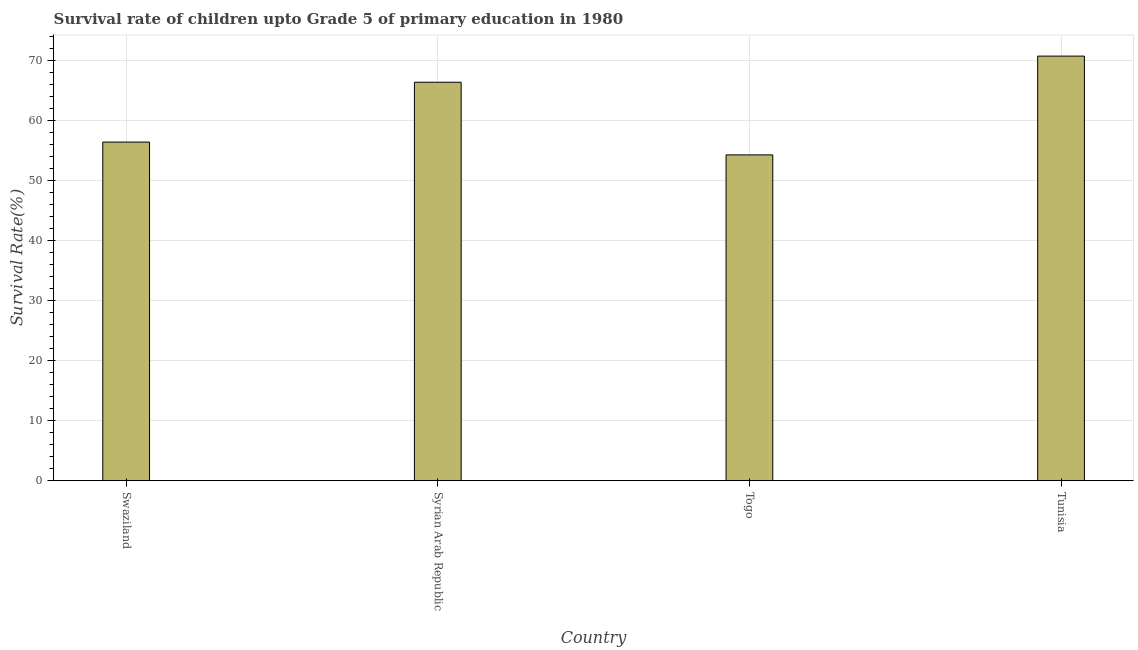Does the graph contain any zero values?
Keep it short and to the point. No. What is the title of the graph?
Offer a very short reply. Survival rate of children upto Grade 5 of primary education in 1980 . What is the label or title of the X-axis?
Provide a short and direct response. Country. What is the label or title of the Y-axis?
Ensure brevity in your answer.  Survival Rate(%). What is the survival rate in Swaziland?
Your response must be concise. 56.43. Across all countries, what is the maximum survival rate?
Your answer should be compact. 70.76. Across all countries, what is the minimum survival rate?
Offer a terse response. 54.3. In which country was the survival rate maximum?
Ensure brevity in your answer.  Tunisia. In which country was the survival rate minimum?
Your response must be concise. Togo. What is the sum of the survival rate?
Your answer should be compact. 247.89. What is the difference between the survival rate in Syrian Arab Republic and Togo?
Make the answer very short. 12.1. What is the average survival rate per country?
Your response must be concise. 61.97. What is the median survival rate?
Your answer should be very brief. 61.42. Is the difference between the survival rate in Syrian Arab Republic and Togo greater than the difference between any two countries?
Ensure brevity in your answer.  No. What is the difference between the highest and the second highest survival rate?
Keep it short and to the point. 4.36. Is the sum of the survival rate in Swaziland and Syrian Arab Republic greater than the maximum survival rate across all countries?
Keep it short and to the point. Yes. What is the difference between the highest and the lowest survival rate?
Provide a succinct answer. 16.46. How many bars are there?
Make the answer very short. 4. Are all the bars in the graph horizontal?
Make the answer very short. No. Are the values on the major ticks of Y-axis written in scientific E-notation?
Your response must be concise. No. What is the Survival Rate(%) in Swaziland?
Ensure brevity in your answer.  56.43. What is the Survival Rate(%) of Syrian Arab Republic?
Your answer should be compact. 66.4. What is the Survival Rate(%) in Togo?
Provide a succinct answer. 54.3. What is the Survival Rate(%) in Tunisia?
Ensure brevity in your answer.  70.76. What is the difference between the Survival Rate(%) in Swaziland and Syrian Arab Republic?
Ensure brevity in your answer.  -9.97. What is the difference between the Survival Rate(%) in Swaziland and Togo?
Offer a terse response. 2.14. What is the difference between the Survival Rate(%) in Swaziland and Tunisia?
Give a very brief answer. -14.32. What is the difference between the Survival Rate(%) in Syrian Arab Republic and Togo?
Make the answer very short. 12.1. What is the difference between the Survival Rate(%) in Syrian Arab Republic and Tunisia?
Your answer should be very brief. -4.35. What is the difference between the Survival Rate(%) in Togo and Tunisia?
Make the answer very short. -16.46. What is the ratio of the Survival Rate(%) in Swaziland to that in Togo?
Keep it short and to the point. 1.04. What is the ratio of the Survival Rate(%) in Swaziland to that in Tunisia?
Provide a short and direct response. 0.8. What is the ratio of the Survival Rate(%) in Syrian Arab Republic to that in Togo?
Give a very brief answer. 1.22. What is the ratio of the Survival Rate(%) in Syrian Arab Republic to that in Tunisia?
Give a very brief answer. 0.94. What is the ratio of the Survival Rate(%) in Togo to that in Tunisia?
Offer a terse response. 0.77. 